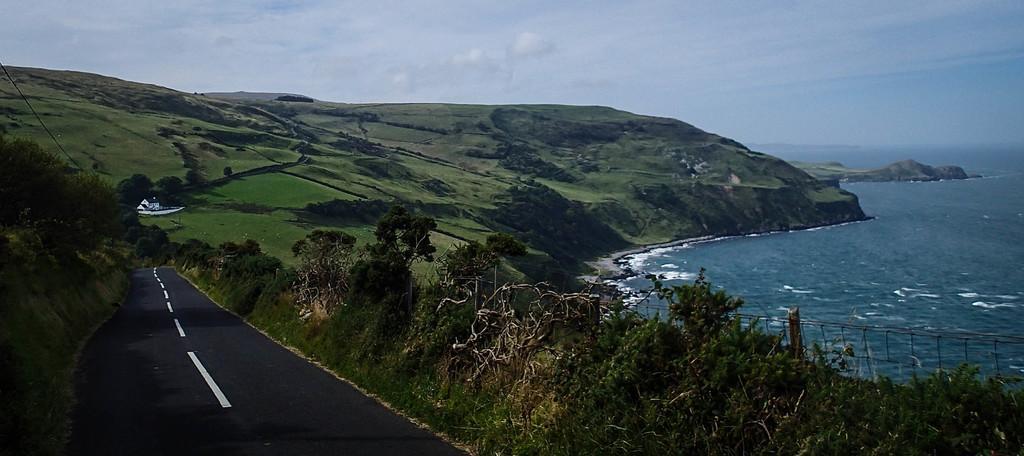Could you give a brief overview of what you see in this image? In this image we can see hills, building, road, trees, sea and sky with clouds. 